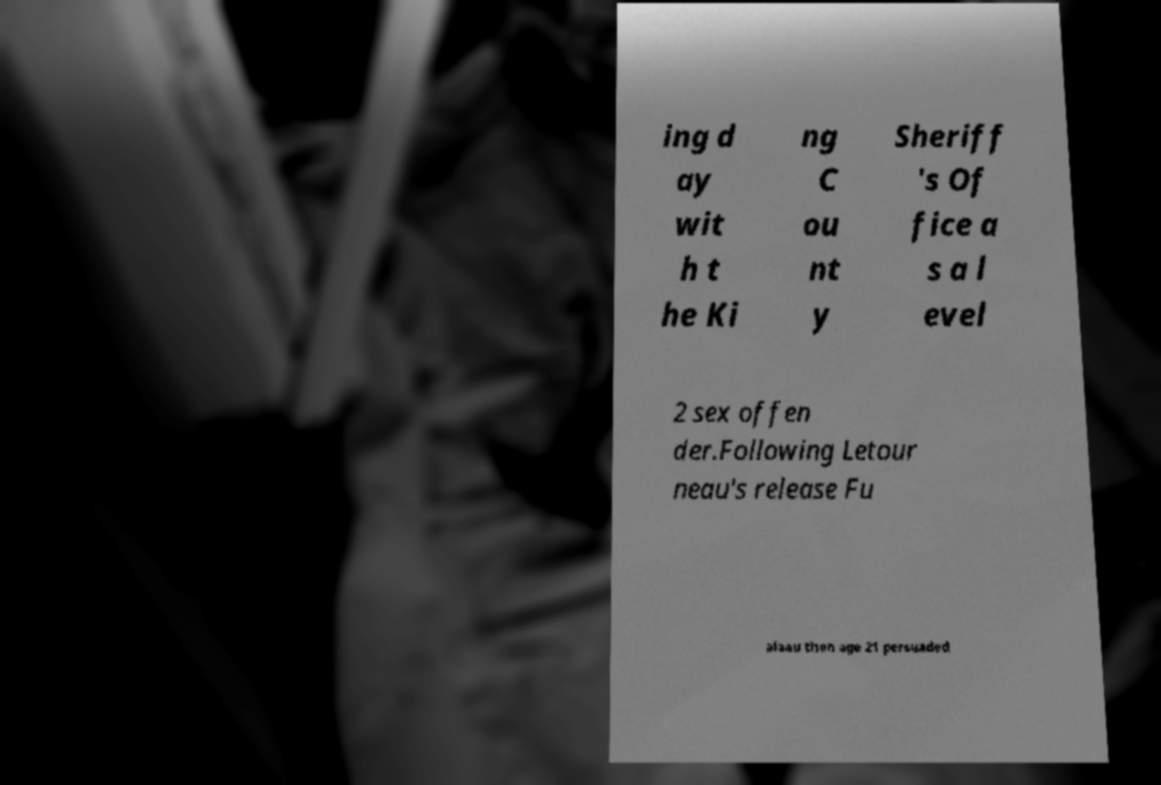Could you assist in decoding the text presented in this image and type it out clearly? ing d ay wit h t he Ki ng C ou nt y Sheriff 's Of fice a s a l evel 2 sex offen der.Following Letour neau's release Fu alaau then age 21 persuaded 